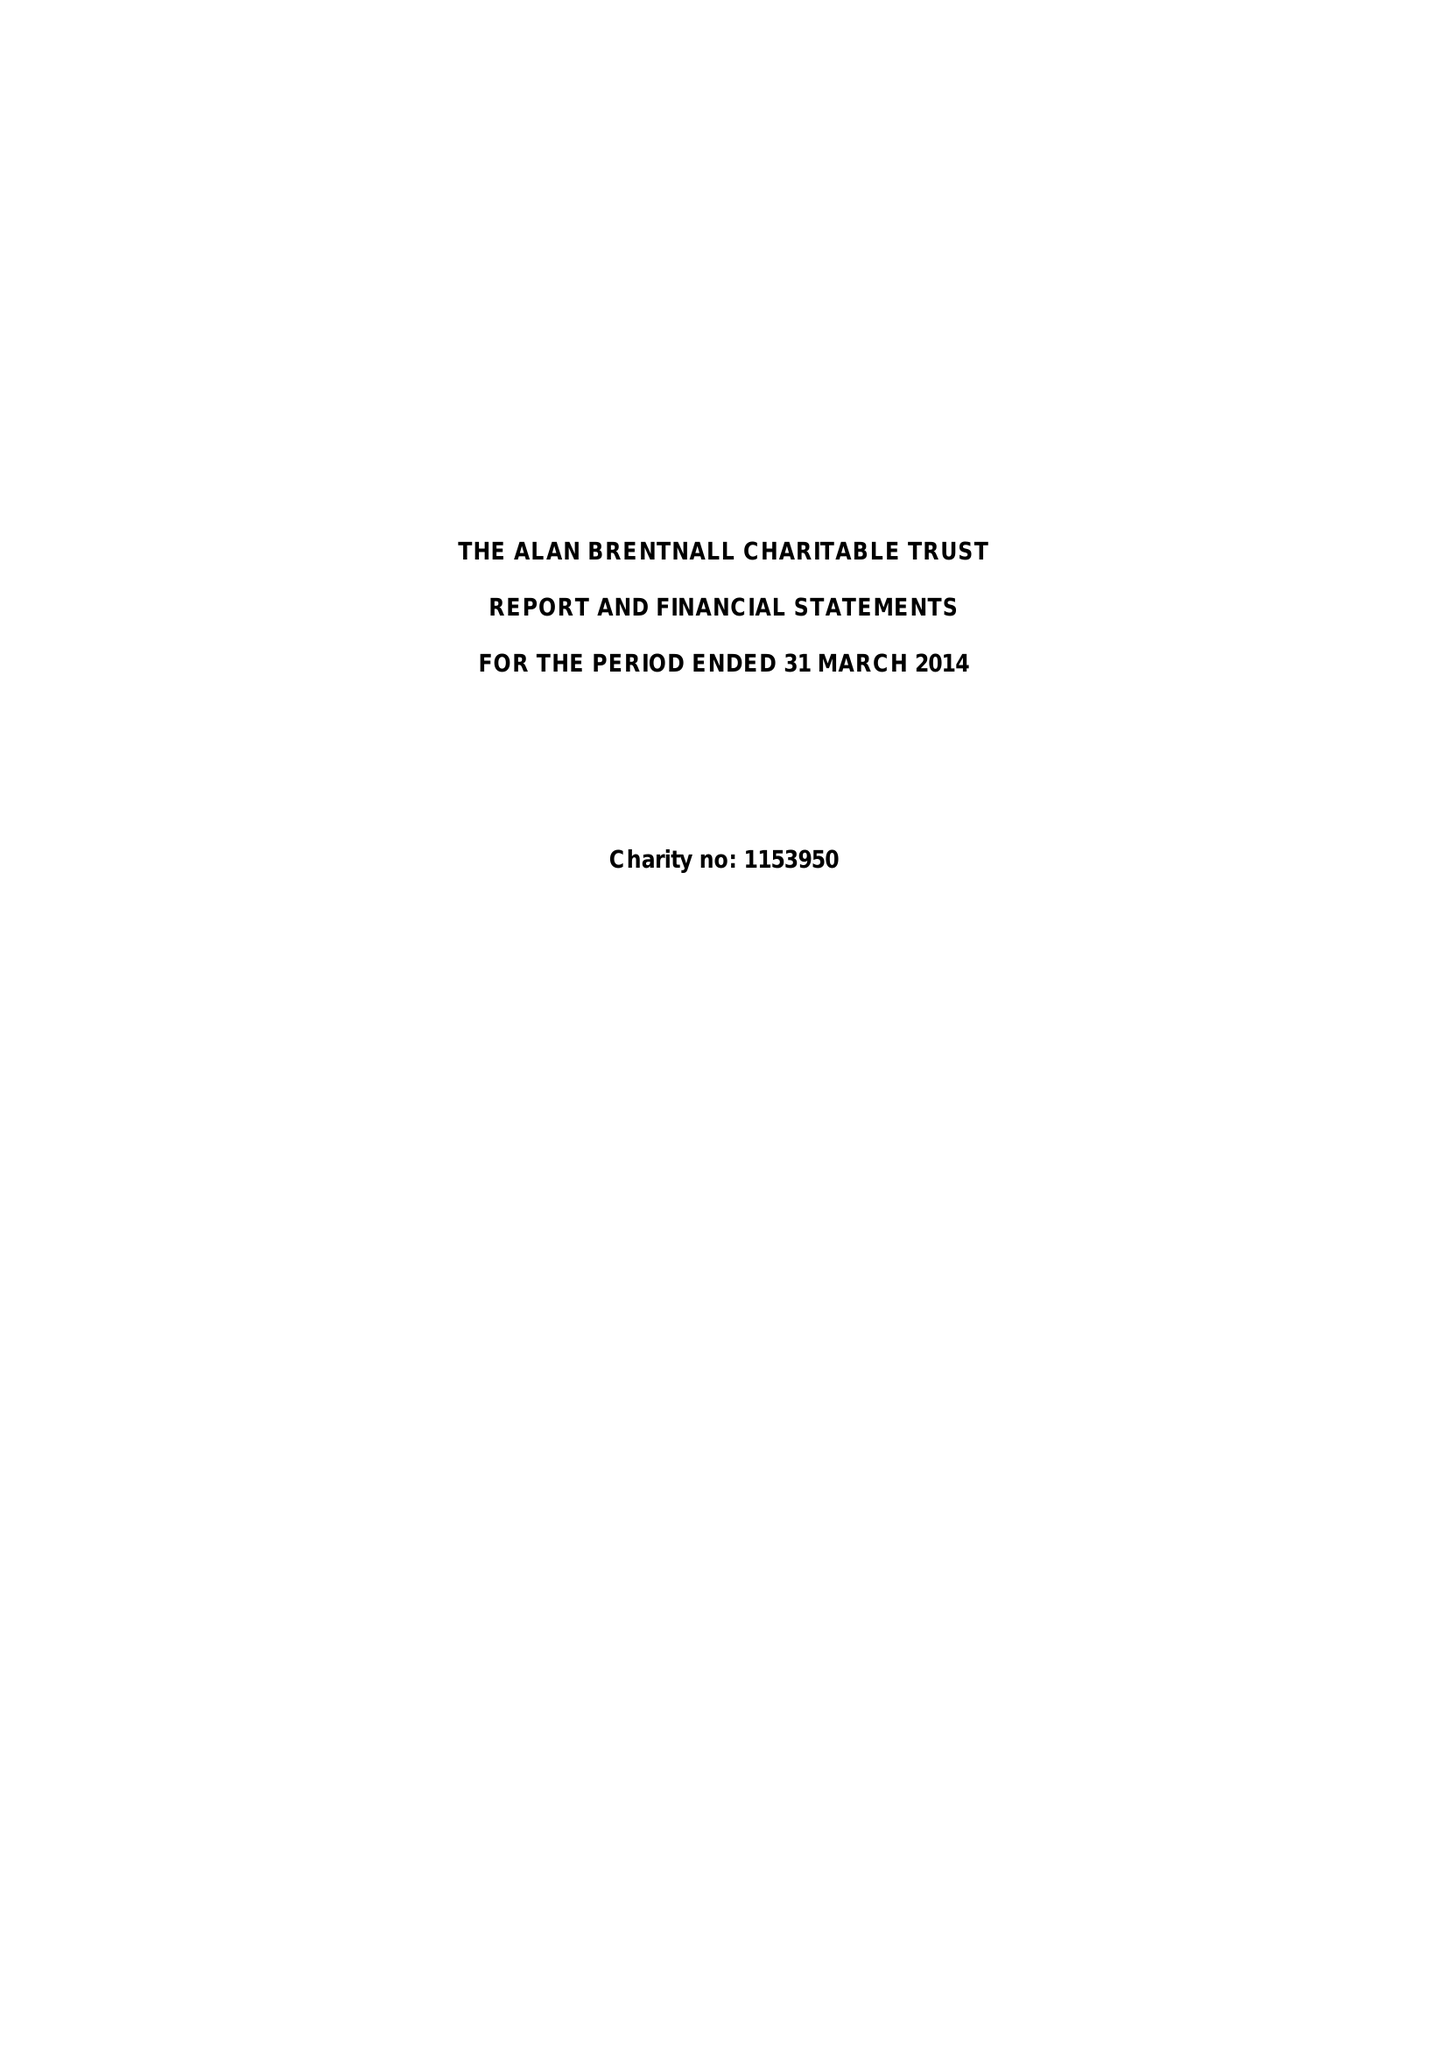What is the value for the charity_name?
Answer the question using a single word or phrase. The Alan Brentnall Charitable Trust 